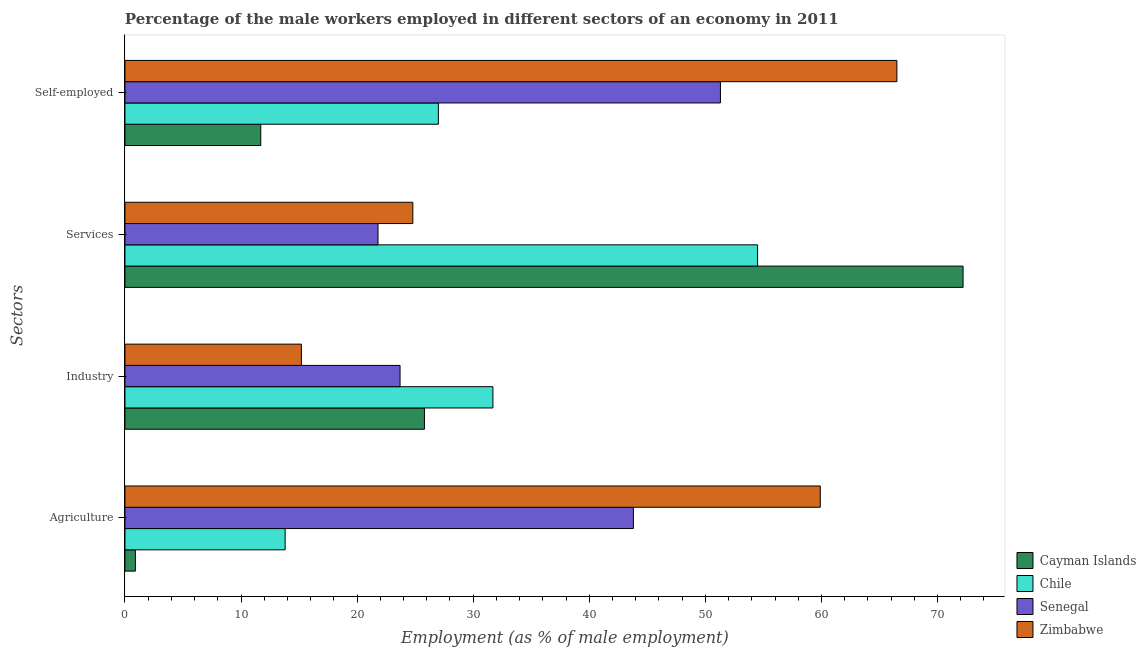How many different coloured bars are there?
Offer a very short reply. 4. Are the number of bars per tick equal to the number of legend labels?
Ensure brevity in your answer.  Yes. Are the number of bars on each tick of the Y-axis equal?
Provide a short and direct response. Yes. How many bars are there on the 2nd tick from the bottom?
Ensure brevity in your answer.  4. What is the label of the 3rd group of bars from the top?
Your response must be concise. Industry. What is the percentage of male workers in industry in Chile?
Ensure brevity in your answer.  31.7. Across all countries, what is the maximum percentage of male workers in agriculture?
Give a very brief answer. 59.9. Across all countries, what is the minimum percentage of male workers in services?
Offer a very short reply. 21.8. In which country was the percentage of male workers in agriculture maximum?
Make the answer very short. Zimbabwe. In which country was the percentage of self employed male workers minimum?
Offer a very short reply. Cayman Islands. What is the total percentage of self employed male workers in the graph?
Offer a terse response. 156.5. What is the difference between the percentage of male workers in services in Zimbabwe and that in Chile?
Provide a succinct answer. -29.7. What is the difference between the percentage of male workers in agriculture in Zimbabwe and the percentage of male workers in services in Senegal?
Keep it short and to the point. 38.1. What is the average percentage of male workers in industry per country?
Provide a succinct answer. 24.1. What is the difference between the percentage of self employed male workers and percentage of male workers in industry in Zimbabwe?
Offer a very short reply. 51.3. In how many countries, is the percentage of male workers in agriculture greater than 20 %?
Your answer should be compact. 2. What is the ratio of the percentage of self employed male workers in Cayman Islands to that in Zimbabwe?
Offer a very short reply. 0.18. Is the difference between the percentage of male workers in industry in Senegal and Chile greater than the difference between the percentage of male workers in agriculture in Senegal and Chile?
Provide a short and direct response. No. What is the difference between the highest and the second highest percentage of male workers in services?
Give a very brief answer. 17.7. What is the difference between the highest and the lowest percentage of self employed male workers?
Provide a succinct answer. 54.8. In how many countries, is the percentage of male workers in industry greater than the average percentage of male workers in industry taken over all countries?
Your answer should be very brief. 2. Is the sum of the percentage of self employed male workers in Senegal and Zimbabwe greater than the maximum percentage of male workers in services across all countries?
Provide a succinct answer. Yes. What does the 1st bar from the top in Self-employed represents?
Your response must be concise. Zimbabwe. What does the 1st bar from the bottom in Self-employed represents?
Offer a terse response. Cayman Islands. Is it the case that in every country, the sum of the percentage of male workers in agriculture and percentage of male workers in industry is greater than the percentage of male workers in services?
Ensure brevity in your answer.  No. Are all the bars in the graph horizontal?
Your response must be concise. Yes. What is the difference between two consecutive major ticks on the X-axis?
Make the answer very short. 10. Are the values on the major ticks of X-axis written in scientific E-notation?
Make the answer very short. No. Does the graph contain any zero values?
Provide a succinct answer. No. Where does the legend appear in the graph?
Make the answer very short. Bottom right. How many legend labels are there?
Offer a very short reply. 4. What is the title of the graph?
Give a very brief answer. Percentage of the male workers employed in different sectors of an economy in 2011. What is the label or title of the X-axis?
Your answer should be compact. Employment (as % of male employment). What is the label or title of the Y-axis?
Give a very brief answer. Sectors. What is the Employment (as % of male employment) of Cayman Islands in Agriculture?
Provide a succinct answer. 0.9. What is the Employment (as % of male employment) of Chile in Agriculture?
Give a very brief answer. 13.8. What is the Employment (as % of male employment) of Senegal in Agriculture?
Your answer should be compact. 43.8. What is the Employment (as % of male employment) in Zimbabwe in Agriculture?
Your answer should be very brief. 59.9. What is the Employment (as % of male employment) of Cayman Islands in Industry?
Your answer should be compact. 25.8. What is the Employment (as % of male employment) in Chile in Industry?
Your response must be concise. 31.7. What is the Employment (as % of male employment) of Senegal in Industry?
Provide a succinct answer. 23.7. What is the Employment (as % of male employment) in Zimbabwe in Industry?
Your answer should be compact. 15.2. What is the Employment (as % of male employment) in Cayman Islands in Services?
Provide a succinct answer. 72.2. What is the Employment (as % of male employment) in Chile in Services?
Keep it short and to the point. 54.5. What is the Employment (as % of male employment) in Senegal in Services?
Offer a terse response. 21.8. What is the Employment (as % of male employment) in Zimbabwe in Services?
Make the answer very short. 24.8. What is the Employment (as % of male employment) in Cayman Islands in Self-employed?
Your answer should be compact. 11.7. What is the Employment (as % of male employment) in Senegal in Self-employed?
Your answer should be very brief. 51.3. What is the Employment (as % of male employment) of Zimbabwe in Self-employed?
Your response must be concise. 66.5. Across all Sectors, what is the maximum Employment (as % of male employment) of Cayman Islands?
Offer a terse response. 72.2. Across all Sectors, what is the maximum Employment (as % of male employment) of Chile?
Your answer should be very brief. 54.5. Across all Sectors, what is the maximum Employment (as % of male employment) in Senegal?
Offer a very short reply. 51.3. Across all Sectors, what is the maximum Employment (as % of male employment) in Zimbabwe?
Ensure brevity in your answer.  66.5. Across all Sectors, what is the minimum Employment (as % of male employment) in Cayman Islands?
Provide a short and direct response. 0.9. Across all Sectors, what is the minimum Employment (as % of male employment) of Chile?
Keep it short and to the point. 13.8. Across all Sectors, what is the minimum Employment (as % of male employment) in Senegal?
Your response must be concise. 21.8. Across all Sectors, what is the minimum Employment (as % of male employment) of Zimbabwe?
Provide a succinct answer. 15.2. What is the total Employment (as % of male employment) in Cayman Islands in the graph?
Keep it short and to the point. 110.6. What is the total Employment (as % of male employment) in Chile in the graph?
Your answer should be very brief. 127. What is the total Employment (as % of male employment) in Senegal in the graph?
Your answer should be very brief. 140.6. What is the total Employment (as % of male employment) in Zimbabwe in the graph?
Offer a very short reply. 166.4. What is the difference between the Employment (as % of male employment) in Cayman Islands in Agriculture and that in Industry?
Your answer should be very brief. -24.9. What is the difference between the Employment (as % of male employment) in Chile in Agriculture and that in Industry?
Provide a succinct answer. -17.9. What is the difference between the Employment (as % of male employment) of Senegal in Agriculture and that in Industry?
Keep it short and to the point. 20.1. What is the difference between the Employment (as % of male employment) of Zimbabwe in Agriculture and that in Industry?
Ensure brevity in your answer.  44.7. What is the difference between the Employment (as % of male employment) in Cayman Islands in Agriculture and that in Services?
Your response must be concise. -71.3. What is the difference between the Employment (as % of male employment) of Chile in Agriculture and that in Services?
Ensure brevity in your answer.  -40.7. What is the difference between the Employment (as % of male employment) in Senegal in Agriculture and that in Services?
Ensure brevity in your answer.  22. What is the difference between the Employment (as % of male employment) of Zimbabwe in Agriculture and that in Services?
Offer a terse response. 35.1. What is the difference between the Employment (as % of male employment) in Cayman Islands in Agriculture and that in Self-employed?
Your answer should be compact. -10.8. What is the difference between the Employment (as % of male employment) in Chile in Agriculture and that in Self-employed?
Your response must be concise. -13.2. What is the difference between the Employment (as % of male employment) in Senegal in Agriculture and that in Self-employed?
Provide a short and direct response. -7.5. What is the difference between the Employment (as % of male employment) in Zimbabwe in Agriculture and that in Self-employed?
Your response must be concise. -6.6. What is the difference between the Employment (as % of male employment) of Cayman Islands in Industry and that in Services?
Your response must be concise. -46.4. What is the difference between the Employment (as % of male employment) of Chile in Industry and that in Services?
Offer a very short reply. -22.8. What is the difference between the Employment (as % of male employment) in Senegal in Industry and that in Services?
Make the answer very short. 1.9. What is the difference between the Employment (as % of male employment) in Cayman Islands in Industry and that in Self-employed?
Offer a very short reply. 14.1. What is the difference between the Employment (as % of male employment) of Senegal in Industry and that in Self-employed?
Your response must be concise. -27.6. What is the difference between the Employment (as % of male employment) in Zimbabwe in Industry and that in Self-employed?
Offer a very short reply. -51.3. What is the difference between the Employment (as % of male employment) of Cayman Islands in Services and that in Self-employed?
Your answer should be very brief. 60.5. What is the difference between the Employment (as % of male employment) of Senegal in Services and that in Self-employed?
Make the answer very short. -29.5. What is the difference between the Employment (as % of male employment) in Zimbabwe in Services and that in Self-employed?
Provide a succinct answer. -41.7. What is the difference between the Employment (as % of male employment) of Cayman Islands in Agriculture and the Employment (as % of male employment) of Chile in Industry?
Offer a terse response. -30.8. What is the difference between the Employment (as % of male employment) in Cayman Islands in Agriculture and the Employment (as % of male employment) in Senegal in Industry?
Provide a short and direct response. -22.8. What is the difference between the Employment (as % of male employment) in Cayman Islands in Agriculture and the Employment (as % of male employment) in Zimbabwe in Industry?
Your answer should be compact. -14.3. What is the difference between the Employment (as % of male employment) in Chile in Agriculture and the Employment (as % of male employment) in Senegal in Industry?
Make the answer very short. -9.9. What is the difference between the Employment (as % of male employment) of Chile in Agriculture and the Employment (as % of male employment) of Zimbabwe in Industry?
Your answer should be compact. -1.4. What is the difference between the Employment (as % of male employment) of Senegal in Agriculture and the Employment (as % of male employment) of Zimbabwe in Industry?
Your answer should be compact. 28.6. What is the difference between the Employment (as % of male employment) of Cayman Islands in Agriculture and the Employment (as % of male employment) of Chile in Services?
Provide a succinct answer. -53.6. What is the difference between the Employment (as % of male employment) of Cayman Islands in Agriculture and the Employment (as % of male employment) of Senegal in Services?
Your answer should be very brief. -20.9. What is the difference between the Employment (as % of male employment) in Cayman Islands in Agriculture and the Employment (as % of male employment) in Zimbabwe in Services?
Give a very brief answer. -23.9. What is the difference between the Employment (as % of male employment) in Chile in Agriculture and the Employment (as % of male employment) in Senegal in Services?
Give a very brief answer. -8. What is the difference between the Employment (as % of male employment) in Chile in Agriculture and the Employment (as % of male employment) in Zimbabwe in Services?
Give a very brief answer. -11. What is the difference between the Employment (as % of male employment) of Senegal in Agriculture and the Employment (as % of male employment) of Zimbabwe in Services?
Provide a succinct answer. 19. What is the difference between the Employment (as % of male employment) of Cayman Islands in Agriculture and the Employment (as % of male employment) of Chile in Self-employed?
Your answer should be compact. -26.1. What is the difference between the Employment (as % of male employment) of Cayman Islands in Agriculture and the Employment (as % of male employment) of Senegal in Self-employed?
Your answer should be compact. -50.4. What is the difference between the Employment (as % of male employment) of Cayman Islands in Agriculture and the Employment (as % of male employment) of Zimbabwe in Self-employed?
Your answer should be very brief. -65.6. What is the difference between the Employment (as % of male employment) in Chile in Agriculture and the Employment (as % of male employment) in Senegal in Self-employed?
Offer a terse response. -37.5. What is the difference between the Employment (as % of male employment) of Chile in Agriculture and the Employment (as % of male employment) of Zimbabwe in Self-employed?
Provide a short and direct response. -52.7. What is the difference between the Employment (as % of male employment) in Senegal in Agriculture and the Employment (as % of male employment) in Zimbabwe in Self-employed?
Your answer should be very brief. -22.7. What is the difference between the Employment (as % of male employment) of Cayman Islands in Industry and the Employment (as % of male employment) of Chile in Services?
Make the answer very short. -28.7. What is the difference between the Employment (as % of male employment) in Cayman Islands in Industry and the Employment (as % of male employment) in Zimbabwe in Services?
Your answer should be compact. 1. What is the difference between the Employment (as % of male employment) of Senegal in Industry and the Employment (as % of male employment) of Zimbabwe in Services?
Your answer should be very brief. -1.1. What is the difference between the Employment (as % of male employment) of Cayman Islands in Industry and the Employment (as % of male employment) of Senegal in Self-employed?
Make the answer very short. -25.5. What is the difference between the Employment (as % of male employment) in Cayman Islands in Industry and the Employment (as % of male employment) in Zimbabwe in Self-employed?
Keep it short and to the point. -40.7. What is the difference between the Employment (as % of male employment) in Chile in Industry and the Employment (as % of male employment) in Senegal in Self-employed?
Keep it short and to the point. -19.6. What is the difference between the Employment (as % of male employment) of Chile in Industry and the Employment (as % of male employment) of Zimbabwe in Self-employed?
Your answer should be very brief. -34.8. What is the difference between the Employment (as % of male employment) in Senegal in Industry and the Employment (as % of male employment) in Zimbabwe in Self-employed?
Your answer should be very brief. -42.8. What is the difference between the Employment (as % of male employment) of Cayman Islands in Services and the Employment (as % of male employment) of Chile in Self-employed?
Provide a succinct answer. 45.2. What is the difference between the Employment (as % of male employment) of Cayman Islands in Services and the Employment (as % of male employment) of Senegal in Self-employed?
Offer a very short reply. 20.9. What is the difference between the Employment (as % of male employment) of Cayman Islands in Services and the Employment (as % of male employment) of Zimbabwe in Self-employed?
Offer a very short reply. 5.7. What is the difference between the Employment (as % of male employment) in Chile in Services and the Employment (as % of male employment) in Zimbabwe in Self-employed?
Provide a short and direct response. -12. What is the difference between the Employment (as % of male employment) of Senegal in Services and the Employment (as % of male employment) of Zimbabwe in Self-employed?
Make the answer very short. -44.7. What is the average Employment (as % of male employment) in Cayman Islands per Sectors?
Your answer should be compact. 27.65. What is the average Employment (as % of male employment) in Chile per Sectors?
Provide a succinct answer. 31.75. What is the average Employment (as % of male employment) of Senegal per Sectors?
Your answer should be compact. 35.15. What is the average Employment (as % of male employment) of Zimbabwe per Sectors?
Give a very brief answer. 41.6. What is the difference between the Employment (as % of male employment) in Cayman Islands and Employment (as % of male employment) in Senegal in Agriculture?
Give a very brief answer. -42.9. What is the difference between the Employment (as % of male employment) of Cayman Islands and Employment (as % of male employment) of Zimbabwe in Agriculture?
Provide a succinct answer. -59. What is the difference between the Employment (as % of male employment) in Chile and Employment (as % of male employment) in Zimbabwe in Agriculture?
Your answer should be very brief. -46.1. What is the difference between the Employment (as % of male employment) in Senegal and Employment (as % of male employment) in Zimbabwe in Agriculture?
Provide a short and direct response. -16.1. What is the difference between the Employment (as % of male employment) in Chile and Employment (as % of male employment) in Zimbabwe in Industry?
Provide a succinct answer. 16.5. What is the difference between the Employment (as % of male employment) of Cayman Islands and Employment (as % of male employment) of Senegal in Services?
Keep it short and to the point. 50.4. What is the difference between the Employment (as % of male employment) of Cayman Islands and Employment (as % of male employment) of Zimbabwe in Services?
Make the answer very short. 47.4. What is the difference between the Employment (as % of male employment) in Chile and Employment (as % of male employment) in Senegal in Services?
Offer a very short reply. 32.7. What is the difference between the Employment (as % of male employment) of Chile and Employment (as % of male employment) of Zimbabwe in Services?
Ensure brevity in your answer.  29.7. What is the difference between the Employment (as % of male employment) of Senegal and Employment (as % of male employment) of Zimbabwe in Services?
Offer a very short reply. -3. What is the difference between the Employment (as % of male employment) in Cayman Islands and Employment (as % of male employment) in Chile in Self-employed?
Ensure brevity in your answer.  -15.3. What is the difference between the Employment (as % of male employment) in Cayman Islands and Employment (as % of male employment) in Senegal in Self-employed?
Keep it short and to the point. -39.6. What is the difference between the Employment (as % of male employment) in Cayman Islands and Employment (as % of male employment) in Zimbabwe in Self-employed?
Ensure brevity in your answer.  -54.8. What is the difference between the Employment (as % of male employment) of Chile and Employment (as % of male employment) of Senegal in Self-employed?
Give a very brief answer. -24.3. What is the difference between the Employment (as % of male employment) in Chile and Employment (as % of male employment) in Zimbabwe in Self-employed?
Give a very brief answer. -39.5. What is the difference between the Employment (as % of male employment) of Senegal and Employment (as % of male employment) of Zimbabwe in Self-employed?
Ensure brevity in your answer.  -15.2. What is the ratio of the Employment (as % of male employment) in Cayman Islands in Agriculture to that in Industry?
Provide a succinct answer. 0.03. What is the ratio of the Employment (as % of male employment) in Chile in Agriculture to that in Industry?
Provide a short and direct response. 0.44. What is the ratio of the Employment (as % of male employment) in Senegal in Agriculture to that in Industry?
Provide a succinct answer. 1.85. What is the ratio of the Employment (as % of male employment) of Zimbabwe in Agriculture to that in Industry?
Your answer should be very brief. 3.94. What is the ratio of the Employment (as % of male employment) of Cayman Islands in Agriculture to that in Services?
Give a very brief answer. 0.01. What is the ratio of the Employment (as % of male employment) in Chile in Agriculture to that in Services?
Make the answer very short. 0.25. What is the ratio of the Employment (as % of male employment) of Senegal in Agriculture to that in Services?
Make the answer very short. 2.01. What is the ratio of the Employment (as % of male employment) in Zimbabwe in Agriculture to that in Services?
Your answer should be very brief. 2.42. What is the ratio of the Employment (as % of male employment) in Cayman Islands in Agriculture to that in Self-employed?
Keep it short and to the point. 0.08. What is the ratio of the Employment (as % of male employment) of Chile in Agriculture to that in Self-employed?
Keep it short and to the point. 0.51. What is the ratio of the Employment (as % of male employment) of Senegal in Agriculture to that in Self-employed?
Your response must be concise. 0.85. What is the ratio of the Employment (as % of male employment) in Zimbabwe in Agriculture to that in Self-employed?
Your answer should be very brief. 0.9. What is the ratio of the Employment (as % of male employment) in Cayman Islands in Industry to that in Services?
Make the answer very short. 0.36. What is the ratio of the Employment (as % of male employment) of Chile in Industry to that in Services?
Your response must be concise. 0.58. What is the ratio of the Employment (as % of male employment) in Senegal in Industry to that in Services?
Your answer should be very brief. 1.09. What is the ratio of the Employment (as % of male employment) of Zimbabwe in Industry to that in Services?
Your response must be concise. 0.61. What is the ratio of the Employment (as % of male employment) in Cayman Islands in Industry to that in Self-employed?
Your answer should be compact. 2.21. What is the ratio of the Employment (as % of male employment) of Chile in Industry to that in Self-employed?
Ensure brevity in your answer.  1.17. What is the ratio of the Employment (as % of male employment) of Senegal in Industry to that in Self-employed?
Provide a succinct answer. 0.46. What is the ratio of the Employment (as % of male employment) of Zimbabwe in Industry to that in Self-employed?
Your response must be concise. 0.23. What is the ratio of the Employment (as % of male employment) in Cayman Islands in Services to that in Self-employed?
Keep it short and to the point. 6.17. What is the ratio of the Employment (as % of male employment) in Chile in Services to that in Self-employed?
Give a very brief answer. 2.02. What is the ratio of the Employment (as % of male employment) in Senegal in Services to that in Self-employed?
Provide a succinct answer. 0.42. What is the ratio of the Employment (as % of male employment) in Zimbabwe in Services to that in Self-employed?
Give a very brief answer. 0.37. What is the difference between the highest and the second highest Employment (as % of male employment) in Cayman Islands?
Your answer should be compact. 46.4. What is the difference between the highest and the second highest Employment (as % of male employment) of Chile?
Your response must be concise. 22.8. What is the difference between the highest and the second highest Employment (as % of male employment) in Senegal?
Keep it short and to the point. 7.5. What is the difference between the highest and the second highest Employment (as % of male employment) of Zimbabwe?
Your answer should be very brief. 6.6. What is the difference between the highest and the lowest Employment (as % of male employment) of Cayman Islands?
Your response must be concise. 71.3. What is the difference between the highest and the lowest Employment (as % of male employment) in Chile?
Keep it short and to the point. 40.7. What is the difference between the highest and the lowest Employment (as % of male employment) in Senegal?
Make the answer very short. 29.5. What is the difference between the highest and the lowest Employment (as % of male employment) in Zimbabwe?
Your answer should be very brief. 51.3. 